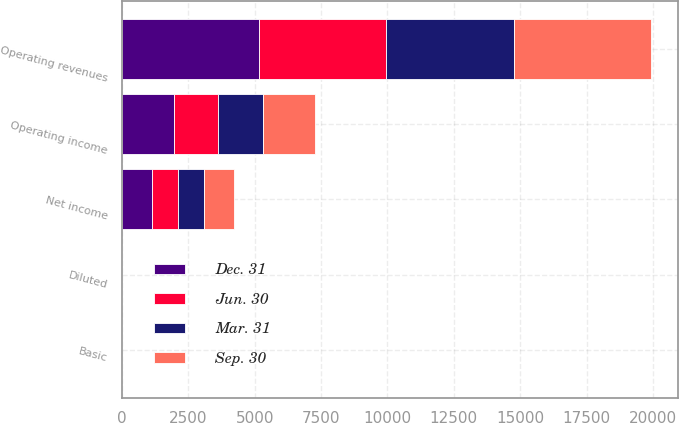<chart> <loc_0><loc_0><loc_500><loc_500><stacked_bar_chart><ecel><fcel>Operating revenues<fcel>Operating income<fcel>Net income<fcel>Basic<fcel>Diluted<nl><fcel>Mar. 31<fcel>4829<fcel>1687<fcel>979<fcel>1.16<fcel>1.16<nl><fcel>Jun. 30<fcel>4770<fcel>1660<fcel>979<fcel>1.17<fcel>1.17<nl><fcel>Dec. 31<fcel>5174<fcel>1960<fcel>1131<fcel>1.36<fcel>1.36<nl><fcel>Sep. 30<fcel>5168<fcel>1965<fcel>1144<fcel>1.4<fcel>1.39<nl></chart> 